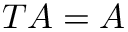<formula> <loc_0><loc_0><loc_500><loc_500>T A = A</formula> 